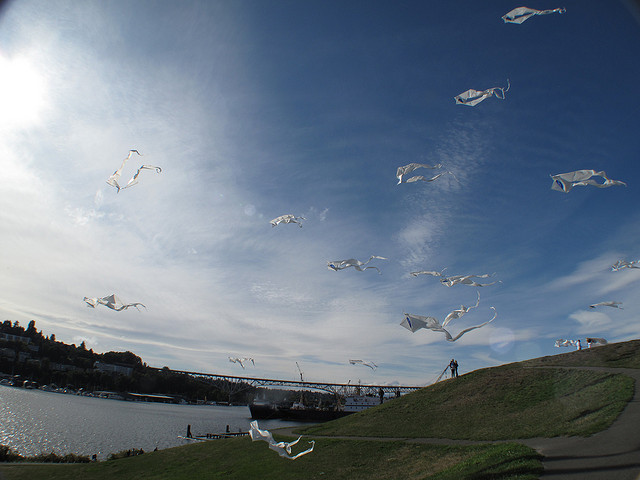<image>Is it cold? I am not sure if it is cold. The answers vary between 'yes' and 'no'. Is it cold? I am not sure if it is cold or not. It can be both cold and not cold. 